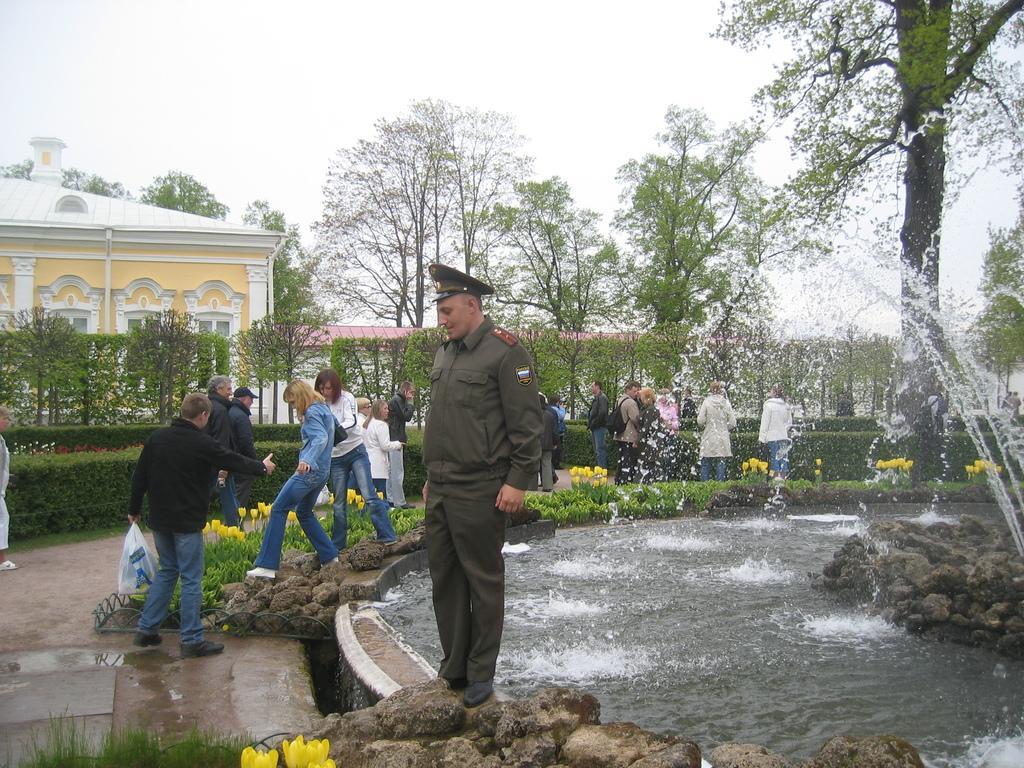Describe this image in one or two sentences. This image consists of many people. In the front, the wearing a cap is standing on the rock. On the right, we can see a fountain. At the bottom, there is water and rocks. In the background, there is a house along with the trees. At the top, there is a sky. 